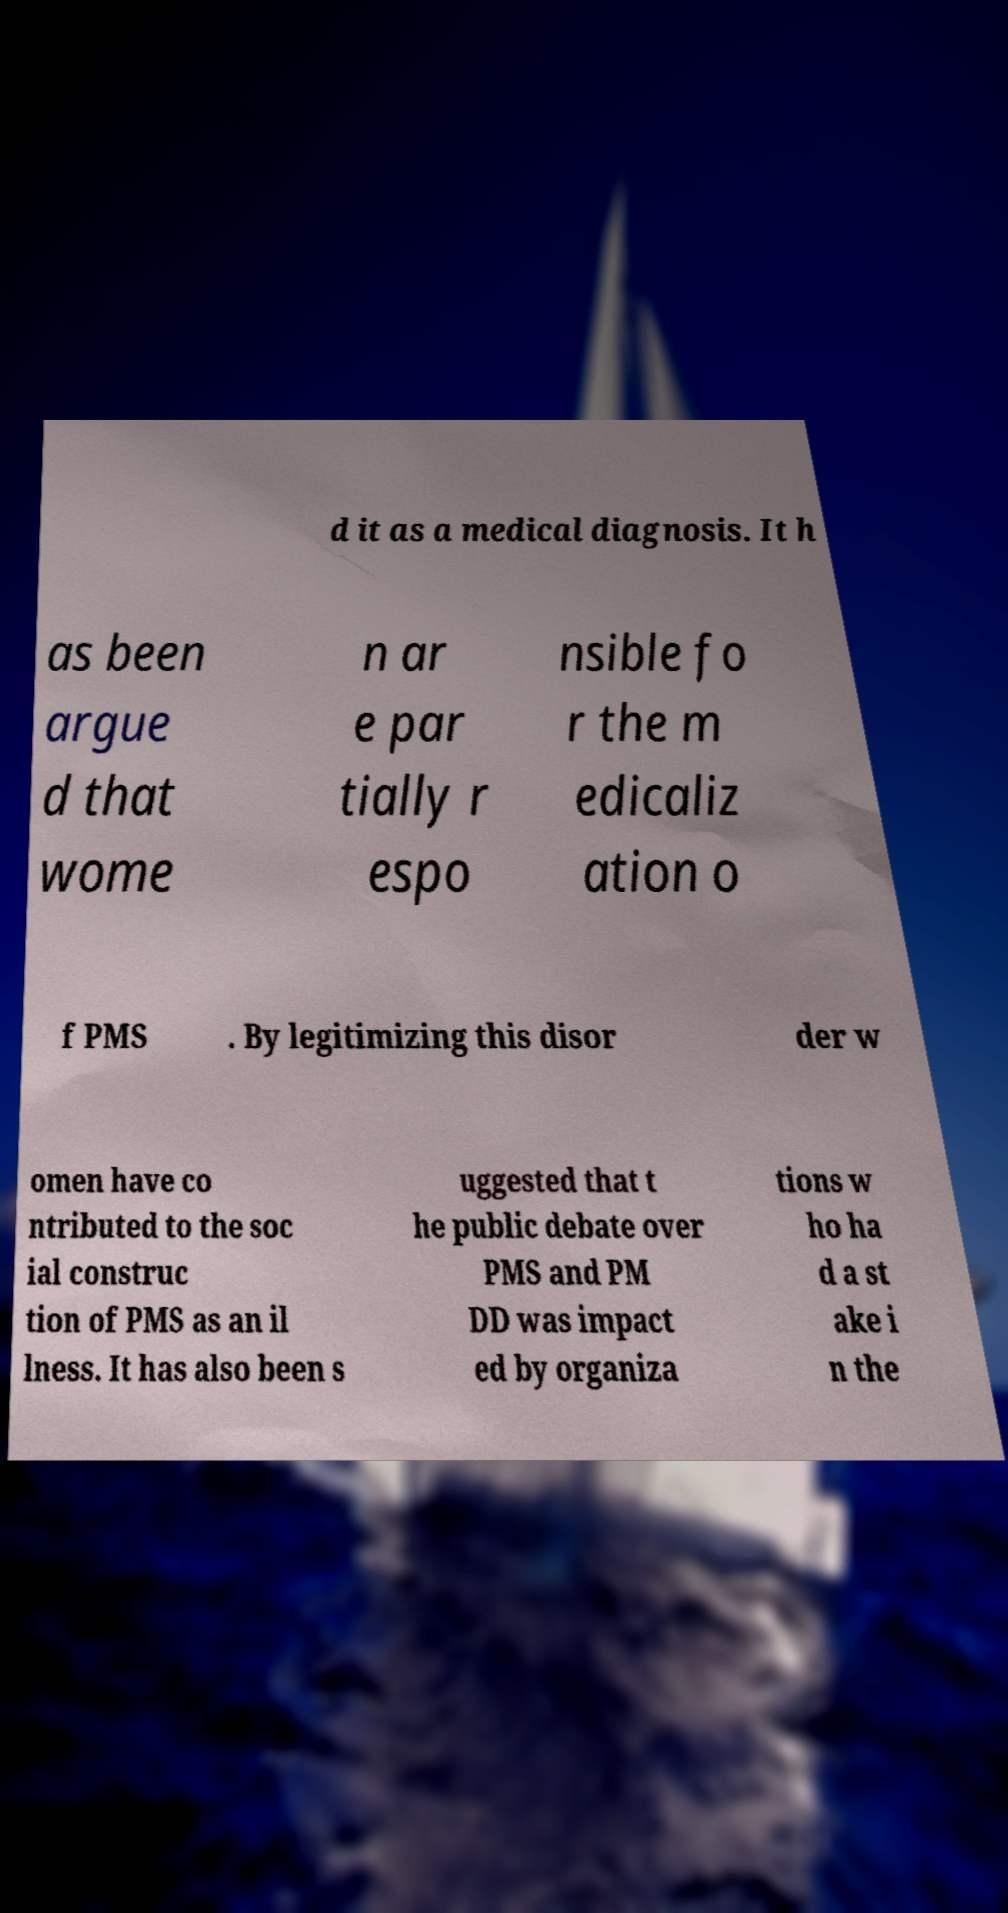For documentation purposes, I need the text within this image transcribed. Could you provide that? d it as a medical diagnosis. It h as been argue d that wome n ar e par tially r espo nsible fo r the m edicaliz ation o f PMS . By legitimizing this disor der w omen have co ntributed to the soc ial construc tion of PMS as an il lness. It has also been s uggested that t he public debate over PMS and PM DD was impact ed by organiza tions w ho ha d a st ake i n the 